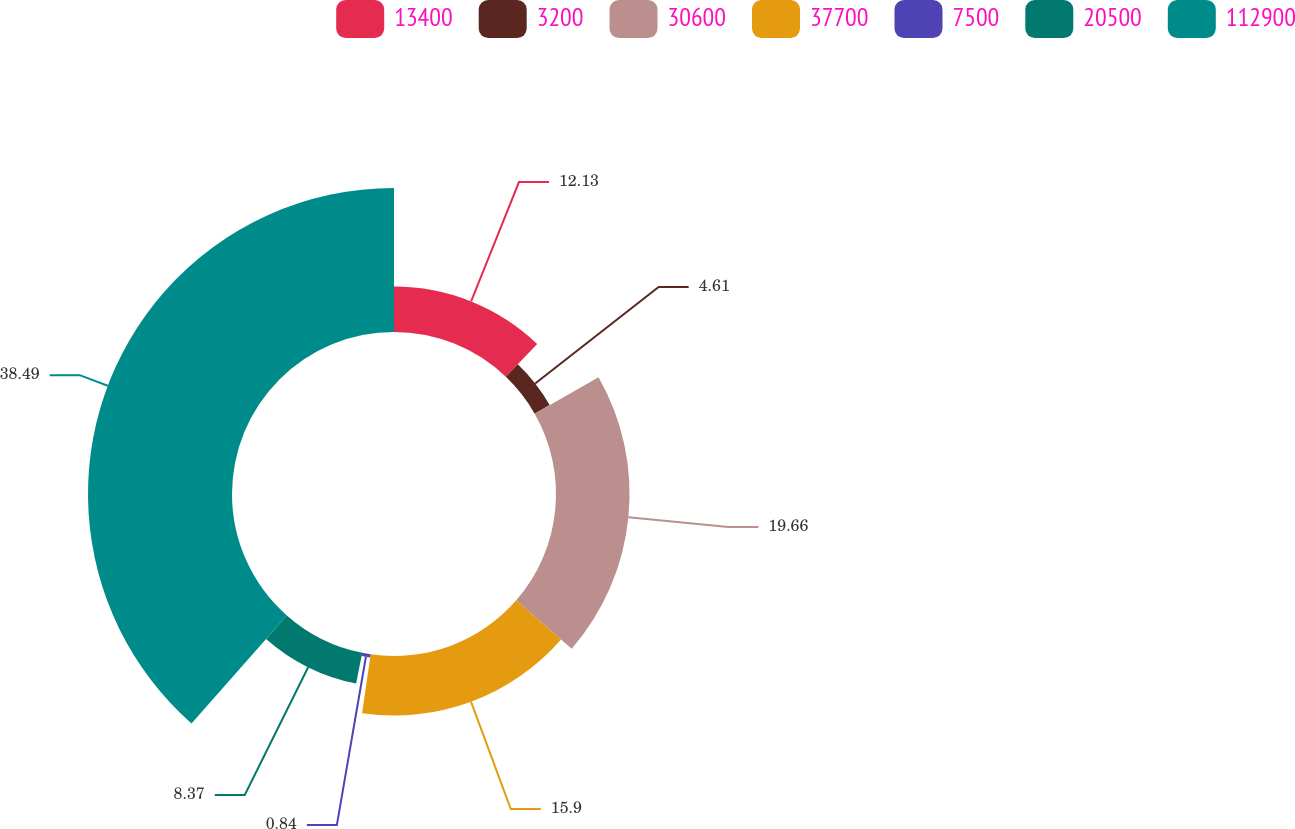Convert chart. <chart><loc_0><loc_0><loc_500><loc_500><pie_chart><fcel>13400<fcel>3200<fcel>30600<fcel>37700<fcel>7500<fcel>20500<fcel>112900<nl><fcel>12.13%<fcel>4.61%<fcel>19.66%<fcel>15.9%<fcel>0.84%<fcel>8.37%<fcel>38.49%<nl></chart> 